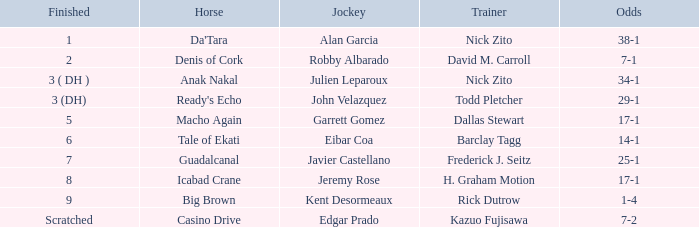What are the Odds for the Horse called Ready's Echo? 29-1. 